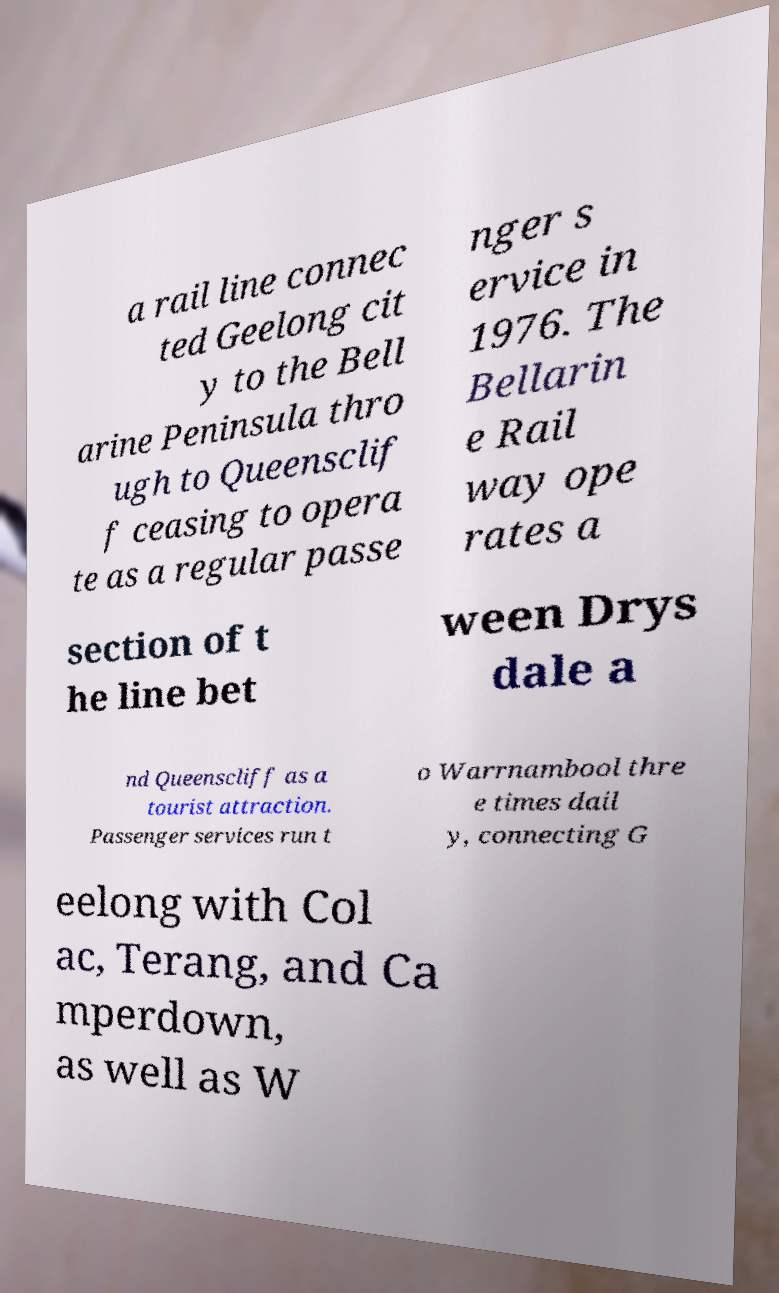Please identify and transcribe the text found in this image. a rail line connec ted Geelong cit y to the Bell arine Peninsula thro ugh to Queensclif f ceasing to opera te as a regular passe nger s ervice in 1976. The Bellarin e Rail way ope rates a section of t he line bet ween Drys dale a nd Queenscliff as a tourist attraction. Passenger services run t o Warrnambool thre e times dail y, connecting G eelong with Col ac, Terang, and Ca mperdown, as well as W 